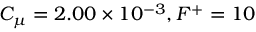<formula> <loc_0><loc_0><loc_500><loc_500>C _ { \mu } = 2 . 0 0 \times 1 0 ^ { - 3 } , F ^ { + } = 1 0</formula> 